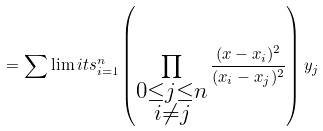<formula> <loc_0><loc_0><loc_500><loc_500>= \sum \lim i t s _ { i = 1 } ^ { n } \left ( \prod _ { \substack { { 0 \leq j \leq n } \\ { i \neq j } } } \frac { ( x - x _ { i } ) ^ { 2 } } { ( x _ { i } - x _ { j } ) ^ { 2 } } \right ) y _ { j }</formula> 